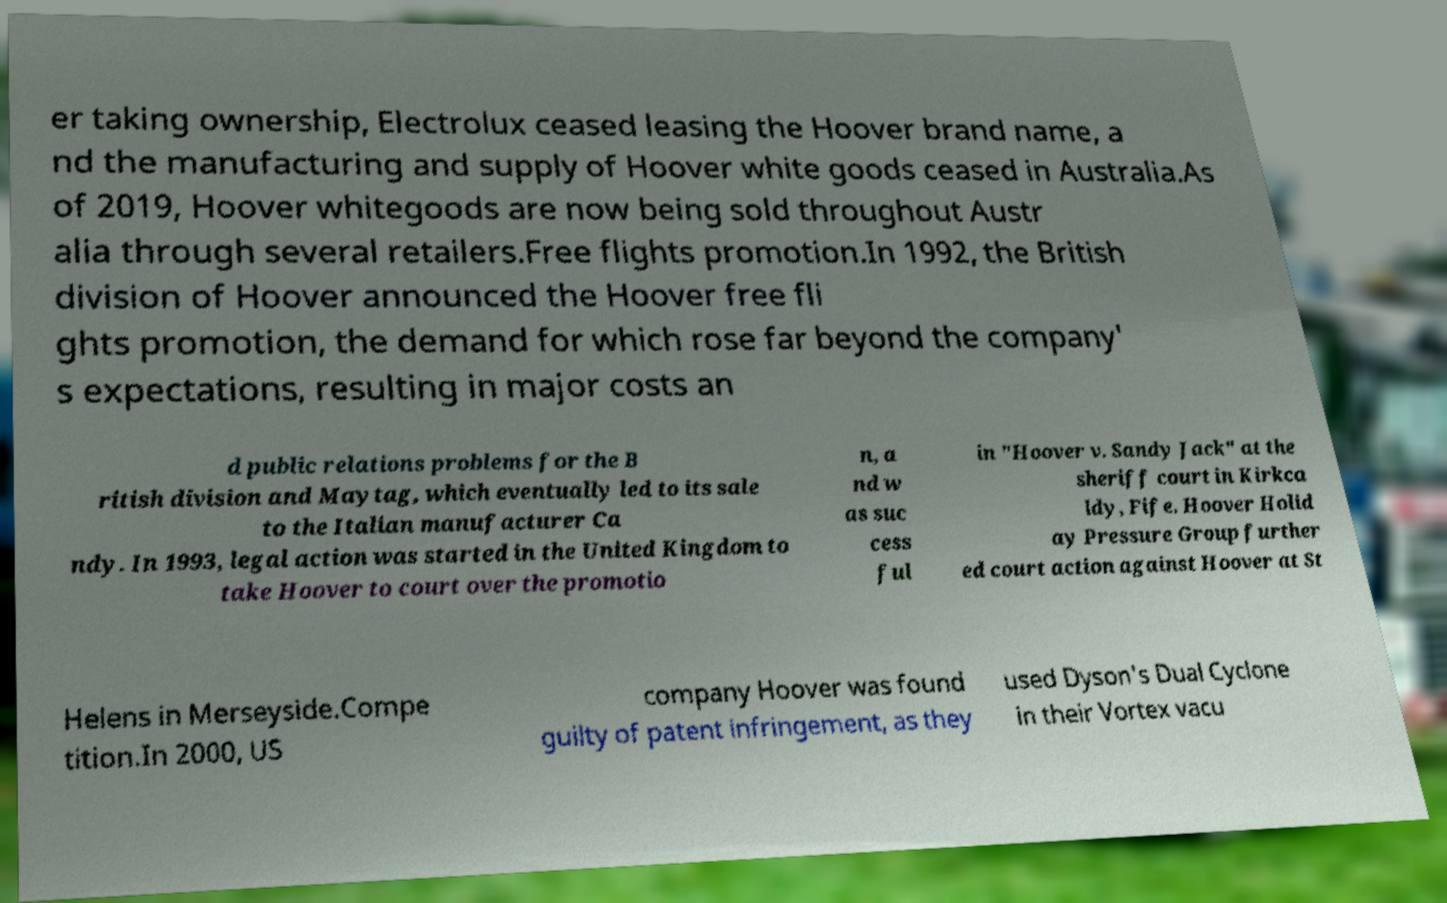For documentation purposes, I need the text within this image transcribed. Could you provide that? er taking ownership, Electrolux ceased leasing the Hoover brand name, a nd the manufacturing and supply of Hoover white goods ceased in Australia.As of 2019, Hoover whitegoods are now being sold throughout Austr alia through several retailers.Free flights promotion.In 1992, the British division of Hoover announced the Hoover free fli ghts promotion, the demand for which rose far beyond the company' s expectations, resulting in major costs an d public relations problems for the B ritish division and Maytag, which eventually led to its sale to the Italian manufacturer Ca ndy. In 1993, legal action was started in the United Kingdom to take Hoover to court over the promotio n, a nd w as suc cess ful in "Hoover v. Sandy Jack" at the sheriff court in Kirkca ldy, Fife. Hoover Holid ay Pressure Group further ed court action against Hoover at St Helens in Merseyside.Compe tition.In 2000, US company Hoover was found guilty of patent infringement, as they used Dyson's Dual Cyclone in their Vortex vacu 